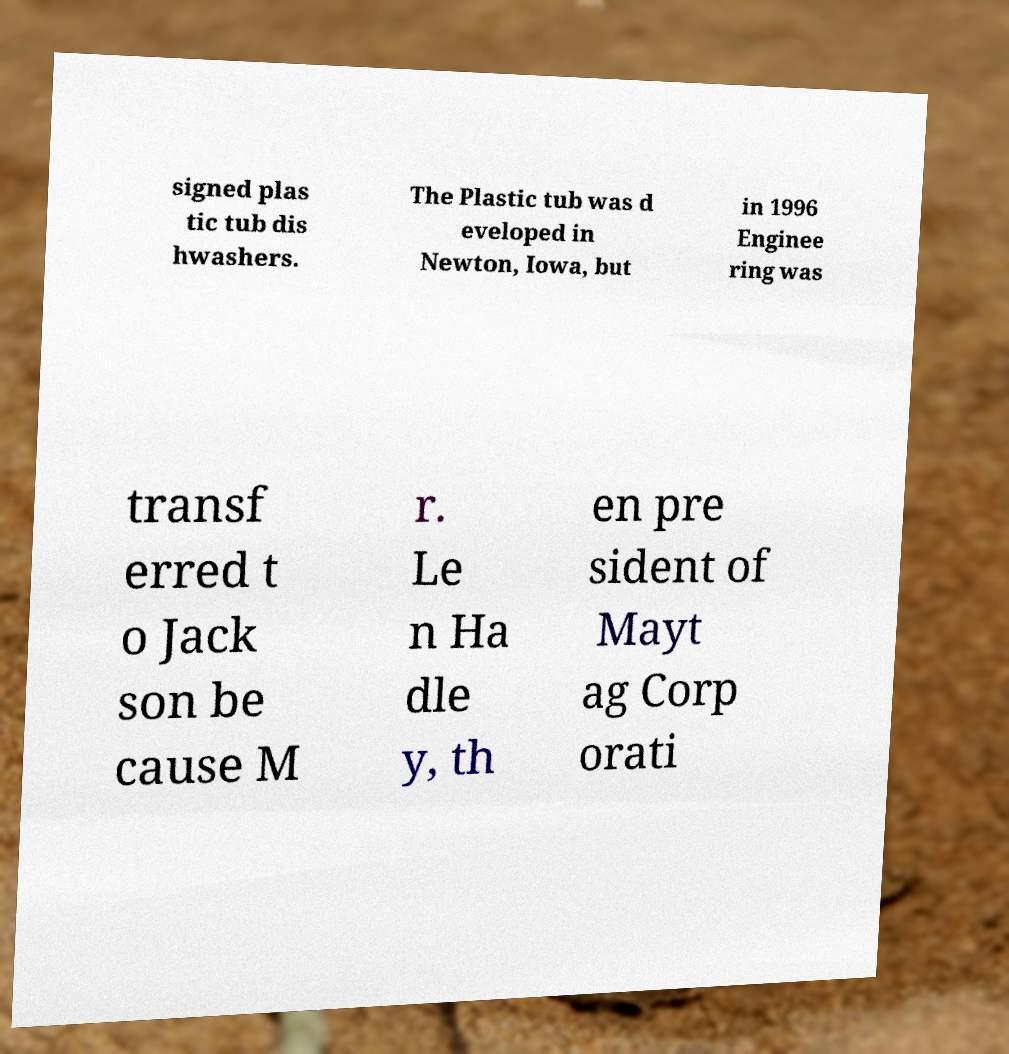Can you read and provide the text displayed in the image?This photo seems to have some interesting text. Can you extract and type it out for me? signed plas tic tub dis hwashers. The Plastic tub was d eveloped in Newton, Iowa, but in 1996 Enginee ring was transf erred t o Jack son be cause M r. Le n Ha dle y, th en pre sident of Mayt ag Corp orati 